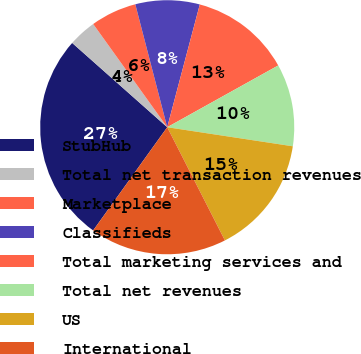<chart> <loc_0><loc_0><loc_500><loc_500><pie_chart><fcel>StubHub<fcel>Total net transaction revenues<fcel>Marketplace<fcel>Classifieds<fcel>Total marketing services and<fcel>Total net revenues<fcel>US<fcel>International<nl><fcel>26.64%<fcel>3.55%<fcel>5.86%<fcel>8.17%<fcel>12.79%<fcel>10.48%<fcel>15.1%<fcel>17.41%<nl></chart> 